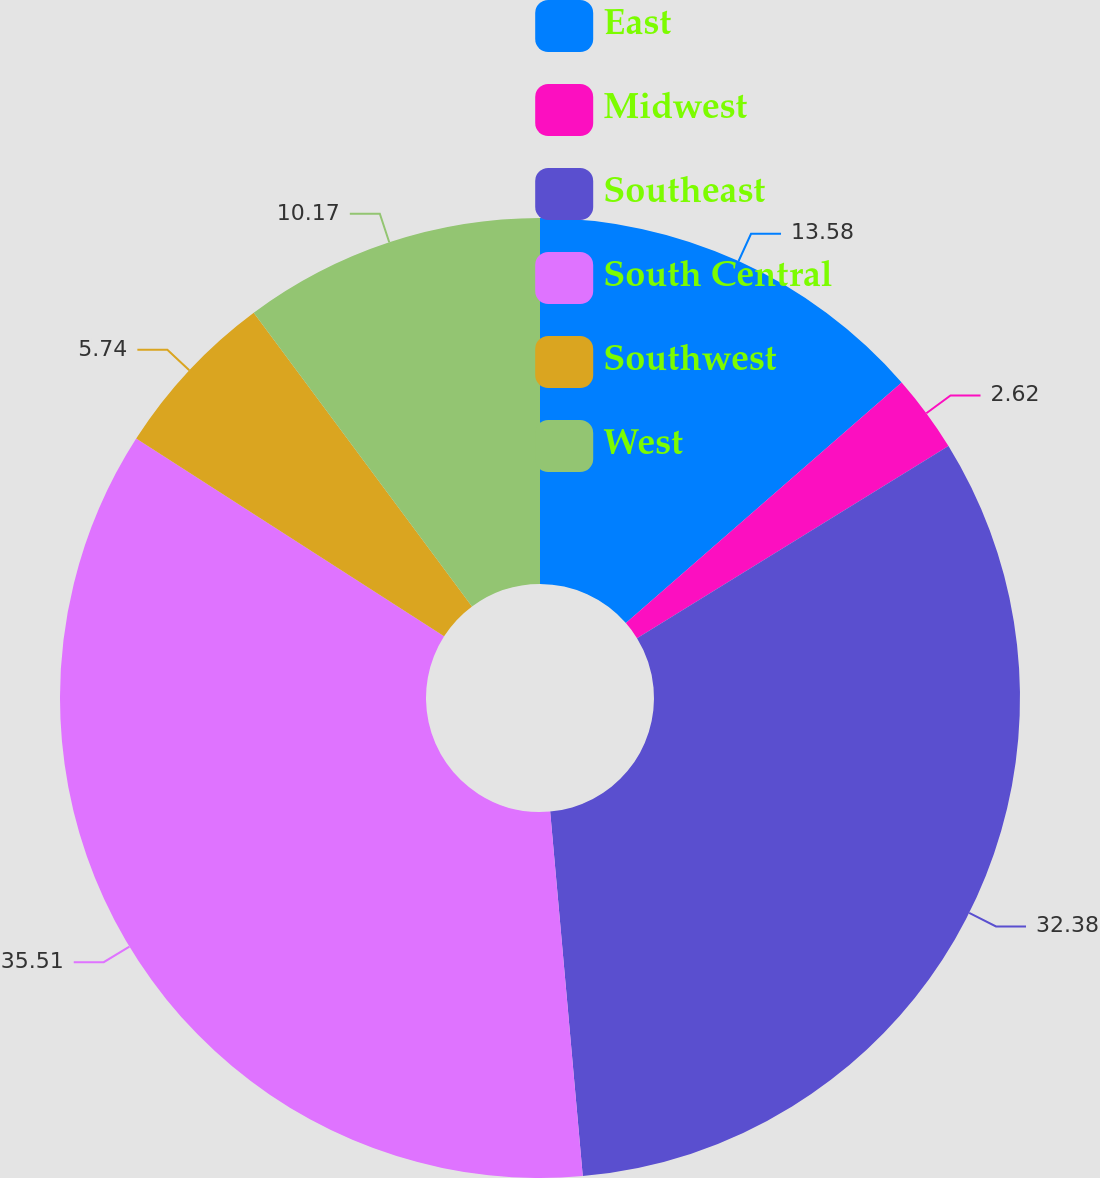Convert chart to OTSL. <chart><loc_0><loc_0><loc_500><loc_500><pie_chart><fcel>East<fcel>Midwest<fcel>Southeast<fcel>South Central<fcel>Southwest<fcel>West<nl><fcel>13.58%<fcel>2.62%<fcel>32.38%<fcel>35.51%<fcel>5.74%<fcel>10.17%<nl></chart> 